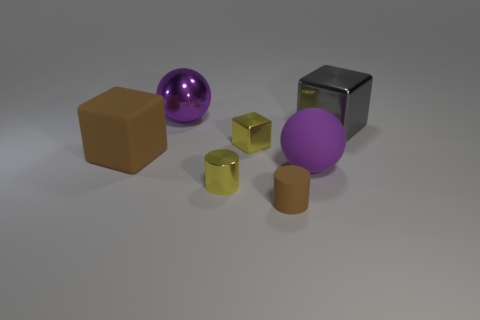How many objects are either yellow shiny objects behind the large brown object or yellow metallic blocks?
Give a very brief answer. 1. There is a big block left of the sphere in front of the big cube that is right of the big brown thing; what is its material?
Give a very brief answer. Rubber. Is the number of purple objects behind the large brown cube greater than the number of yellow cubes that are in front of the tiny rubber cylinder?
Your answer should be compact. Yes. What number of balls are either red matte objects or large purple shiny objects?
Make the answer very short. 1. There is a big matte thing left of the purple ball in front of the gray shiny cube; what number of small cylinders are on the left side of it?
Your answer should be compact. 0. There is a block that is the same color as the small matte thing; what material is it?
Provide a succinct answer. Rubber. Are there more purple objects than rubber things?
Ensure brevity in your answer.  No. Does the matte cylinder have the same size as the purple rubber object?
Your answer should be compact. No. What number of things are big rubber cubes or purple rubber balls?
Ensure brevity in your answer.  2. What is the shape of the tiny metallic thing that is behind the big block that is in front of the metal block to the right of the brown matte cylinder?
Your answer should be very brief. Cube. 